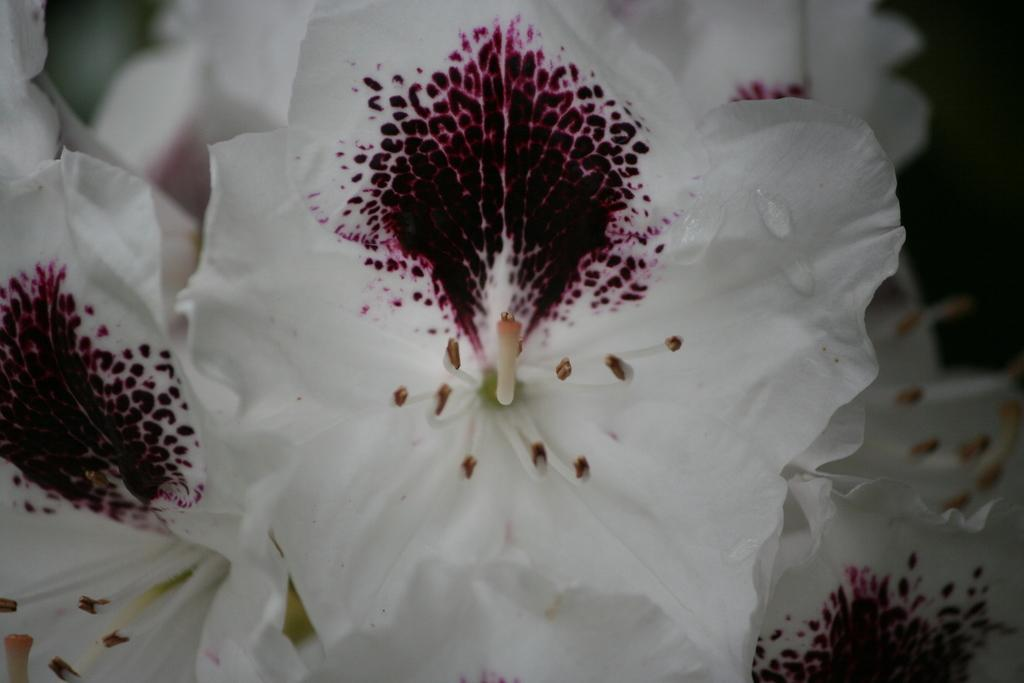What type of flowers can be seen in the image? There are white color flowers in the image. How much salt is sprinkled on the feet of the flowers in the image? There is no salt or feet present in the image; it features white color flowers. 